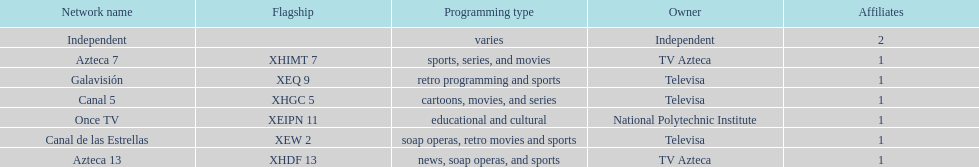How many networks do not air sports? 2. 